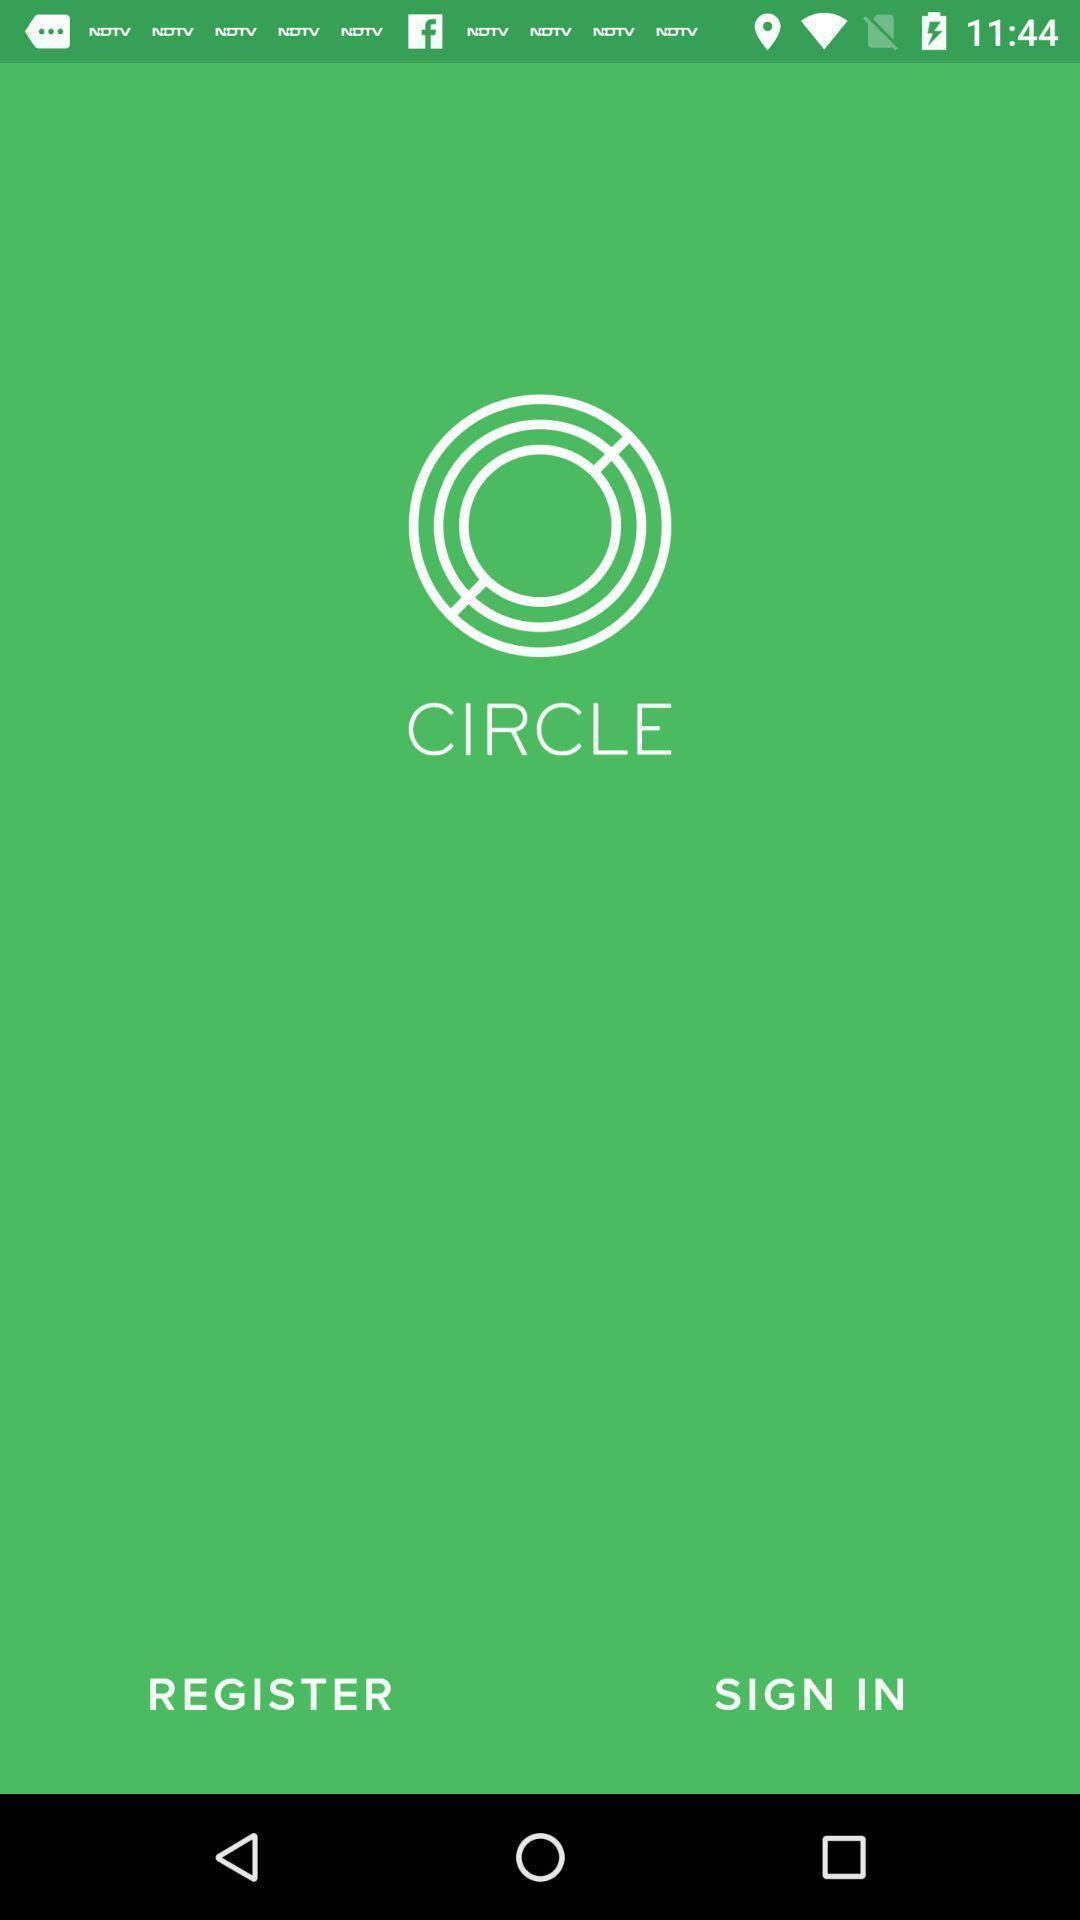Describe this image in words. Welcome page. 